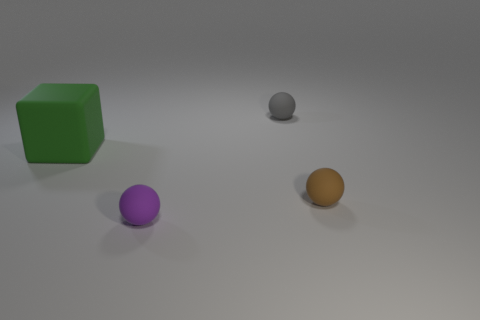What material is the sphere that is to the left of the small matte object that is behind the rubber thing that is to the left of the purple sphere?
Give a very brief answer. Rubber. Are there any small purple things that have the same shape as the small brown matte thing?
Provide a succinct answer. Yes. There is a purple thing that is the same size as the gray rubber ball; what is its shape?
Keep it short and to the point. Sphere. What number of matte things are both in front of the small brown thing and behind the purple ball?
Your answer should be compact. 0. Is the number of large rubber blocks that are in front of the large block less than the number of small purple matte objects?
Keep it short and to the point. Yes. Are there any brown matte things of the same size as the green block?
Your answer should be very brief. No. There is a big cube that is made of the same material as the purple ball; what is its color?
Provide a short and direct response. Green. There is a matte object to the left of the purple matte sphere; what number of rubber spheres are behind it?
Provide a short and direct response. 1. What material is the object that is both right of the big matte cube and behind the brown rubber object?
Your answer should be compact. Rubber. Does the object that is in front of the tiny brown rubber object have the same shape as the green object?
Offer a very short reply. No. 